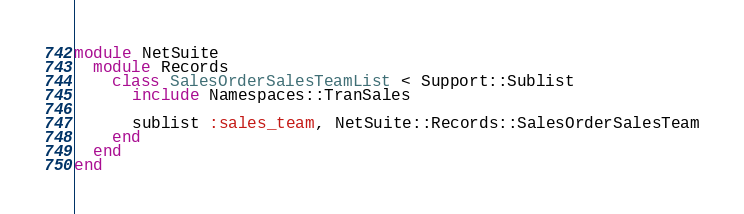Convert code to text. <code><loc_0><loc_0><loc_500><loc_500><_Ruby_>module NetSuite
  module Records
    class SalesOrderSalesTeamList < Support::Sublist
      include Namespaces::TranSales

      sublist :sales_team, NetSuite::Records::SalesOrderSalesTeam
    end
  end
end</code> 